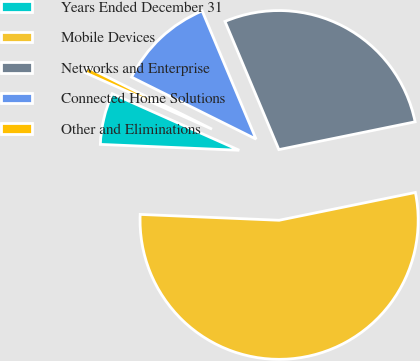Convert chart to OTSL. <chart><loc_0><loc_0><loc_500><loc_500><pie_chart><fcel>Years Ended December 31<fcel>Mobile Devices<fcel>Networks and Enterprise<fcel>Connected Home Solutions<fcel>Other and Eliminations<nl><fcel>6.0%<fcel>53.88%<fcel>28.13%<fcel>11.32%<fcel>0.68%<nl></chart> 